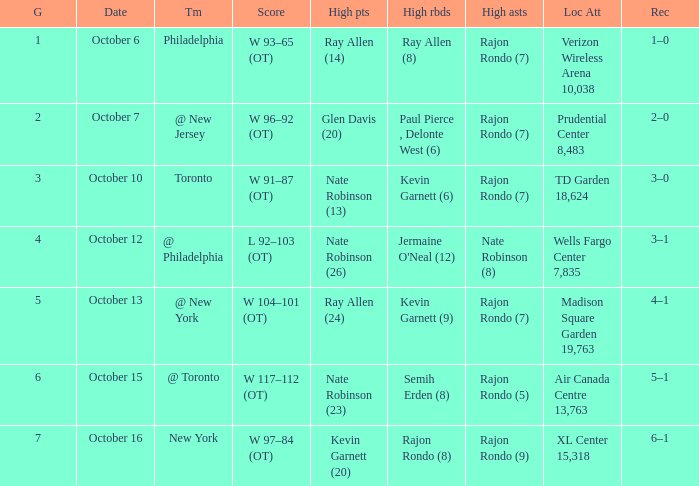Who had the most assists and how many did they have on October 7?  Rajon Rondo (7). 